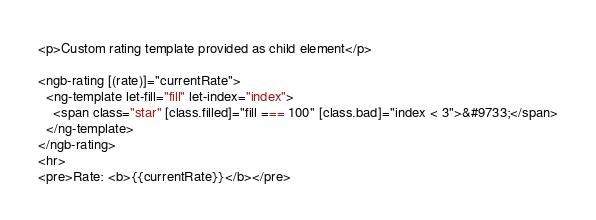Convert code to text. <code><loc_0><loc_0><loc_500><loc_500><_HTML_><p>Custom rating template provided as child element</p>

<ngb-rating [(rate)]="currentRate">
  <ng-template let-fill="fill" let-index="index">
    <span class="star" [class.filled]="fill === 100" [class.bad]="index < 3">&#9733;</span>
  </ng-template>
</ngb-rating>
<hr>
<pre>Rate: <b>{{currentRate}}</b></pre>
</code> 